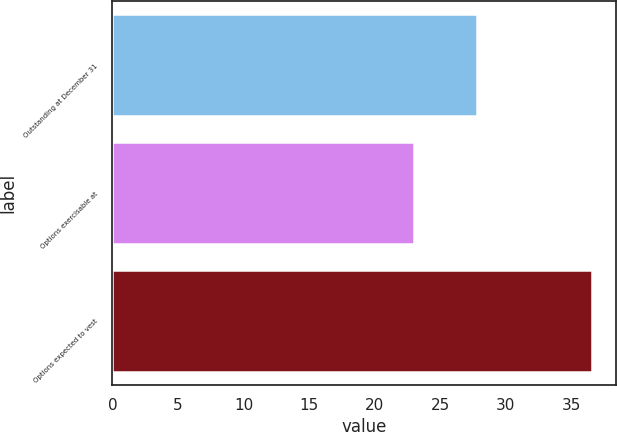Convert chart. <chart><loc_0><loc_0><loc_500><loc_500><bar_chart><fcel>Outstanding at December 31<fcel>Options exercisable at<fcel>Options expected to vest<nl><fcel>27.79<fcel>22.96<fcel>36.56<nl></chart> 